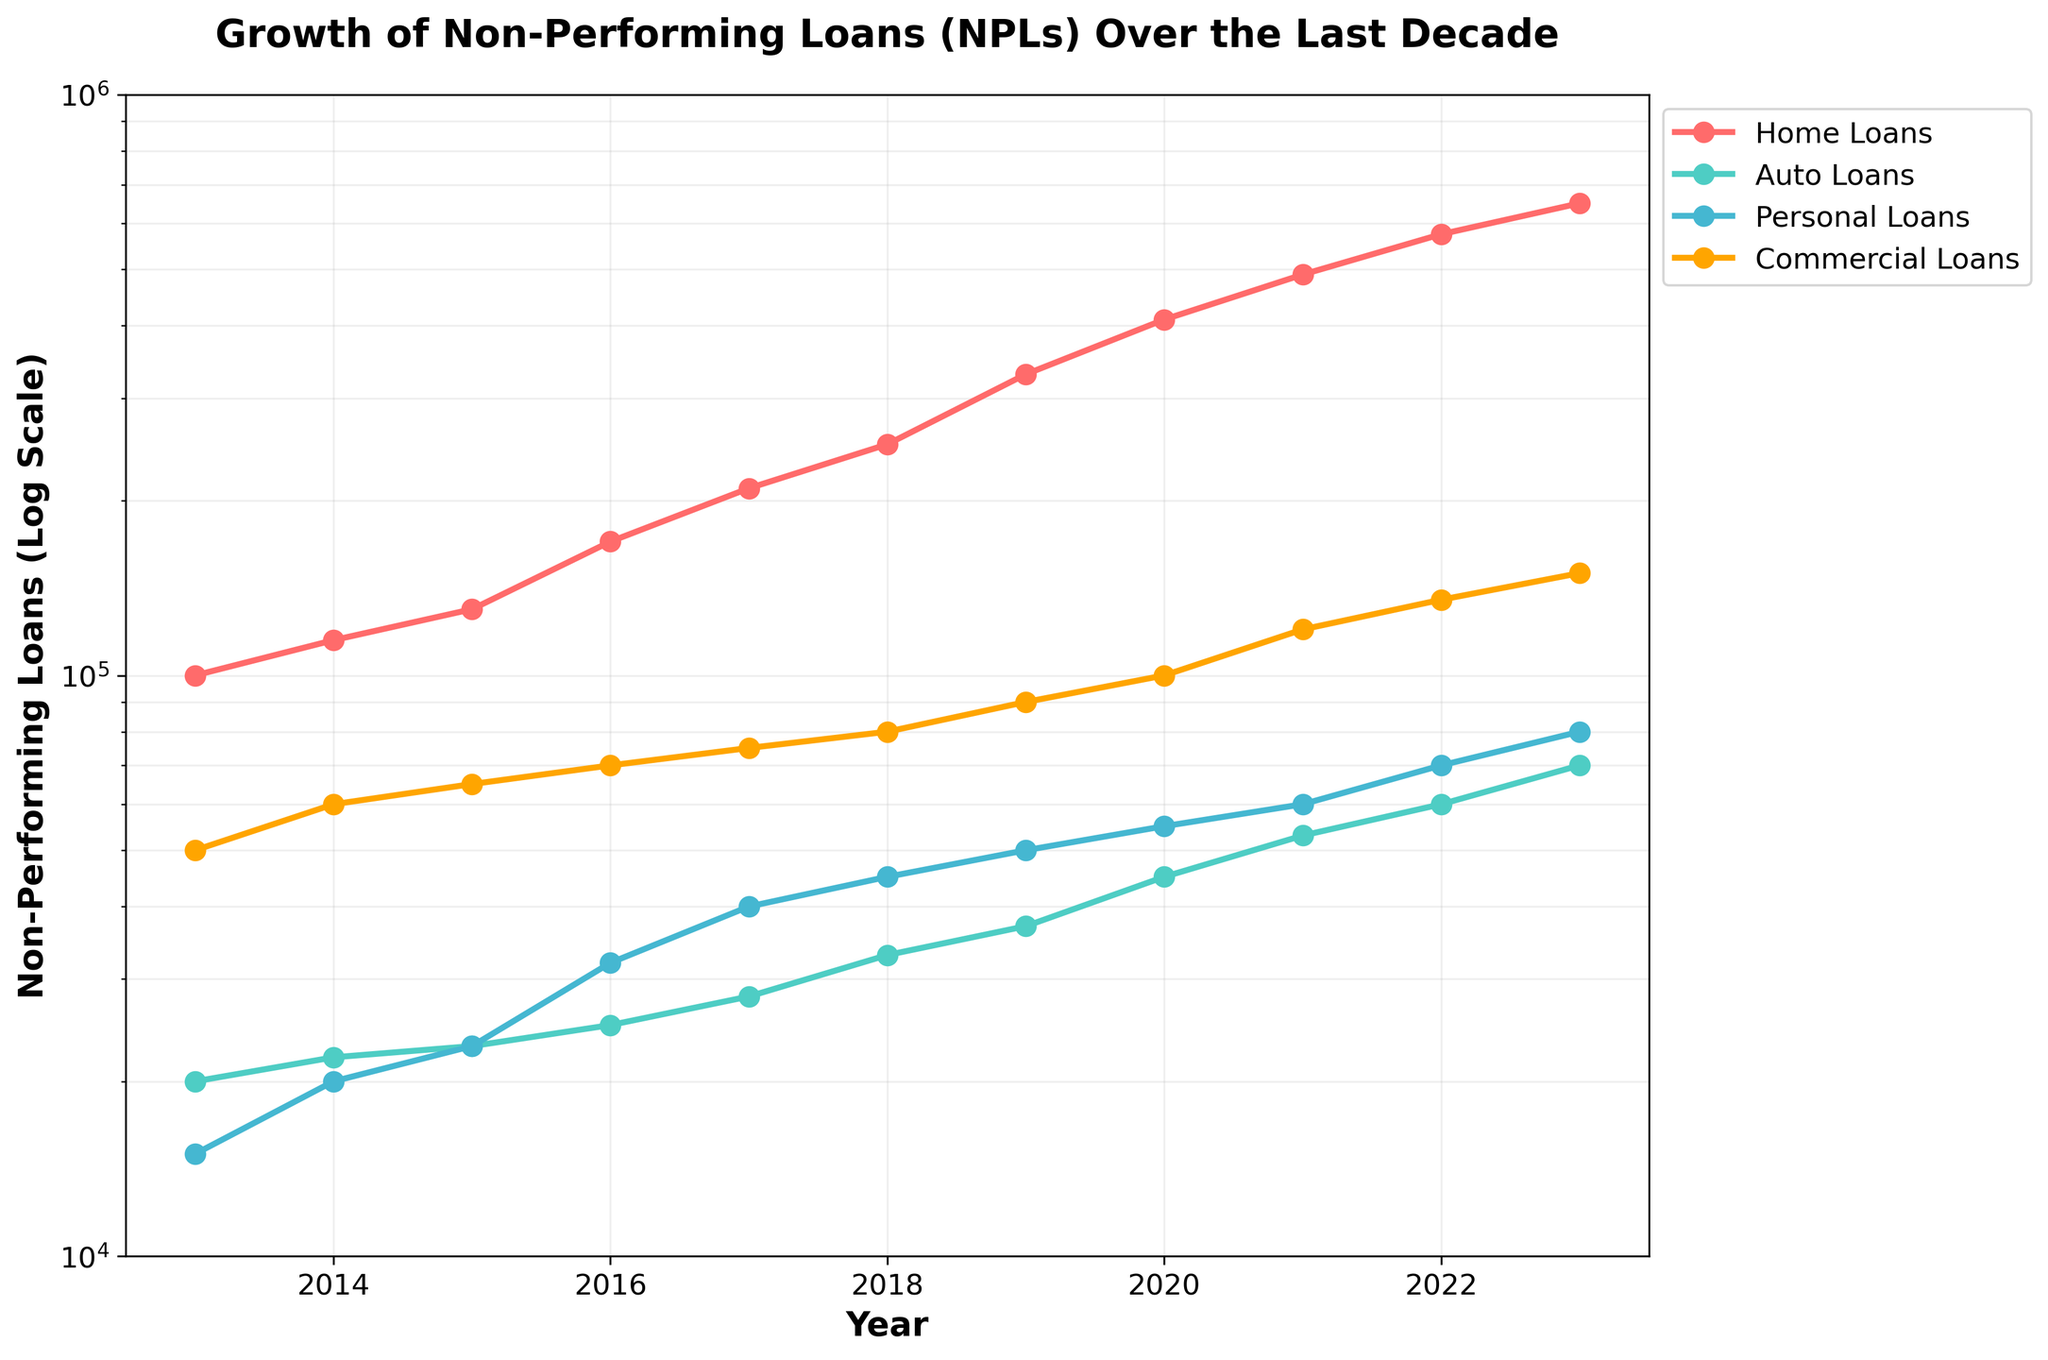What's the title of the plot? The title of the plot is displayed at the top of the figure. It provides an overview of what the figure represents. In this case, the title is "Growth of Non-Performing Loans (NPLs) Over the Last Decade."
Answer: Growth of Non-Performing Loans (NPLs) Over the Last Decade What is the scale of the y-axis? By observing the y-axis, we can see that it is labeled as "Non-Performing Loans (Log Scale)." This indicates that the y-axis is on a logarithmic scale.
Answer: Logarithmic scale What year had the highest amount of Home Loans NPLs? By following the Home Loans data series (marked by a specific color) and identifying the highest data point on the graph, we can see it occurs in 2023.
Answer: 2023 Which loan type had the smallest amount of NPLs in 2013? Comparing the data points for all loan types in 2013, the smallest value corresponds to Personal Loans.
Answer: Personal Loans What was the increase in Commercial Loans NPLs from 2018 to 2023? The NPLs for Commercial Loans in 2018 are 80,000 and in 2023 are 150,000. The increase is calculated as 150,000 - 80,000 = 70,000.
Answer: 70,000 Which loan type experienced the highest average annual growth rate? To determine the average annual growth rate, we need to calculate the percentage increase year-by-year for each loan type and average them out. Home Loans show the largest exponential growth trend on the log scale, indicating the highest average annual growth rate.
Answer: Home Loans Between which years did Auto Loans NPLs see the steepest increase? By examining the slope of the Auto Loans line, the steepest increase occurs between 2019 and 2020, where there is a noticeable upward trend.
Answer: 2019-2020 How do the NPLs for Personal Loans and Auto Loans compare in 2023? From the figure, the NPLs for Personal Loans in 2023 are 80,000, while for Auto Loans, they are 70,000. Comparatively, Personal Loans have higher NPLs than Auto Loans in 2023.
Answer: Personal Loans have higher NPLs What trend do you observe for Commercial Loans NPLs over the depicted decade? Commercial Loans NPLs show a consistent upward trend from 2013 to 2023, indicating a steady increase over the years.
Answer: Consistent upward trend By what factor did the NPLs of Home Loans increase from 2013 to 2023? The NPLs of Home Loans increased from 100,000 in 2013 to 650,000 in 2023. The factor of increase is calculated as 650,000 / 100,000 = 6.5.
Answer: 6.5 